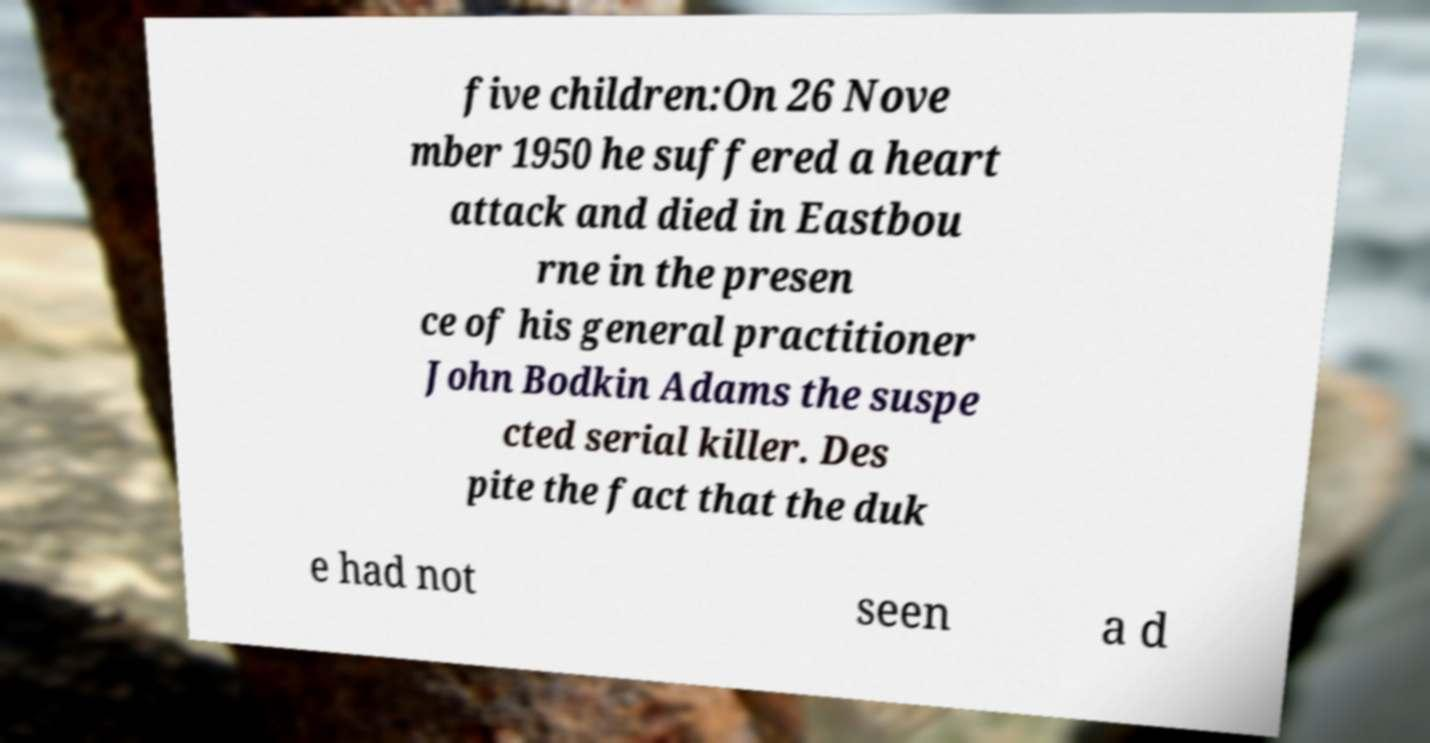What messages or text are displayed in this image? I need them in a readable, typed format. five children:On 26 Nove mber 1950 he suffered a heart attack and died in Eastbou rne in the presen ce of his general practitioner John Bodkin Adams the suspe cted serial killer. Des pite the fact that the duk e had not seen a d 